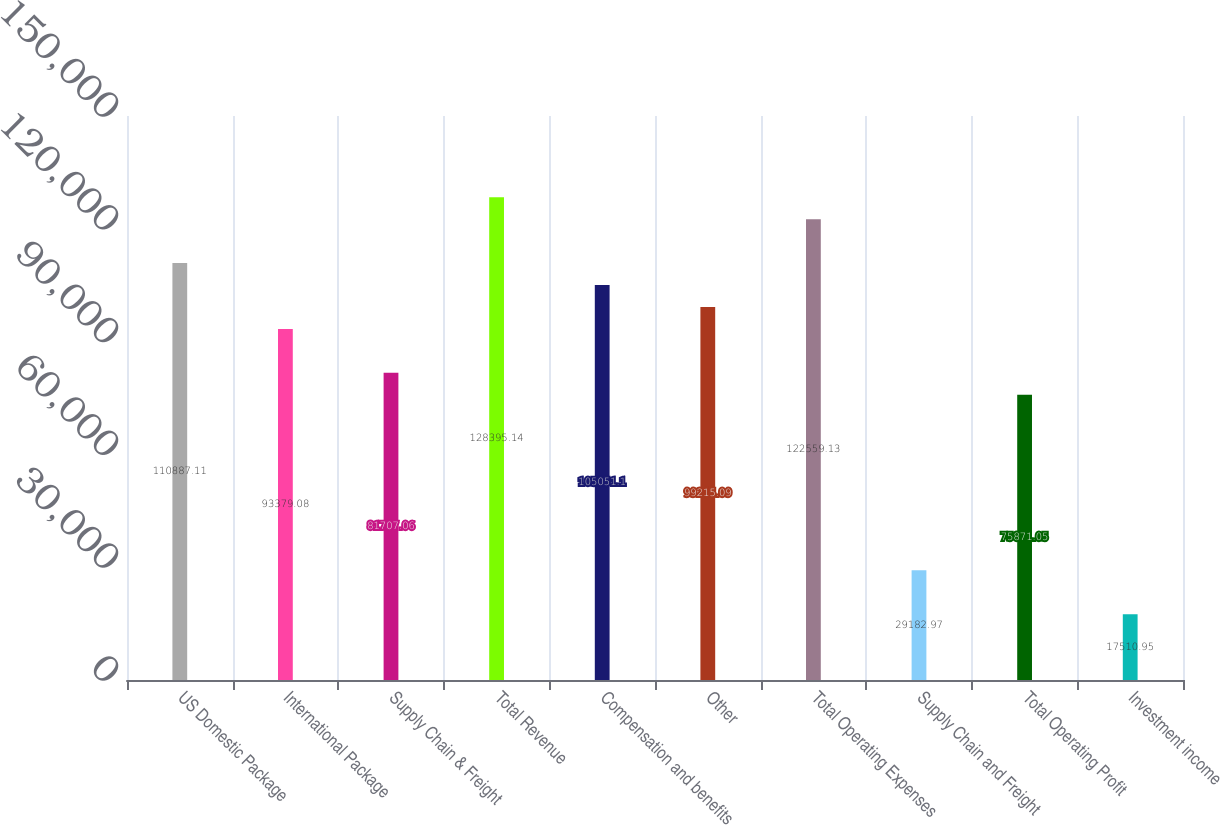<chart> <loc_0><loc_0><loc_500><loc_500><bar_chart><fcel>US Domestic Package<fcel>International Package<fcel>Supply Chain & Freight<fcel>Total Revenue<fcel>Compensation and benefits<fcel>Other<fcel>Total Operating Expenses<fcel>Supply Chain and Freight<fcel>Total Operating Profit<fcel>Investment income<nl><fcel>110887<fcel>93379.1<fcel>81707.1<fcel>128395<fcel>105051<fcel>99215.1<fcel>122559<fcel>29183<fcel>75871.1<fcel>17511<nl></chart> 